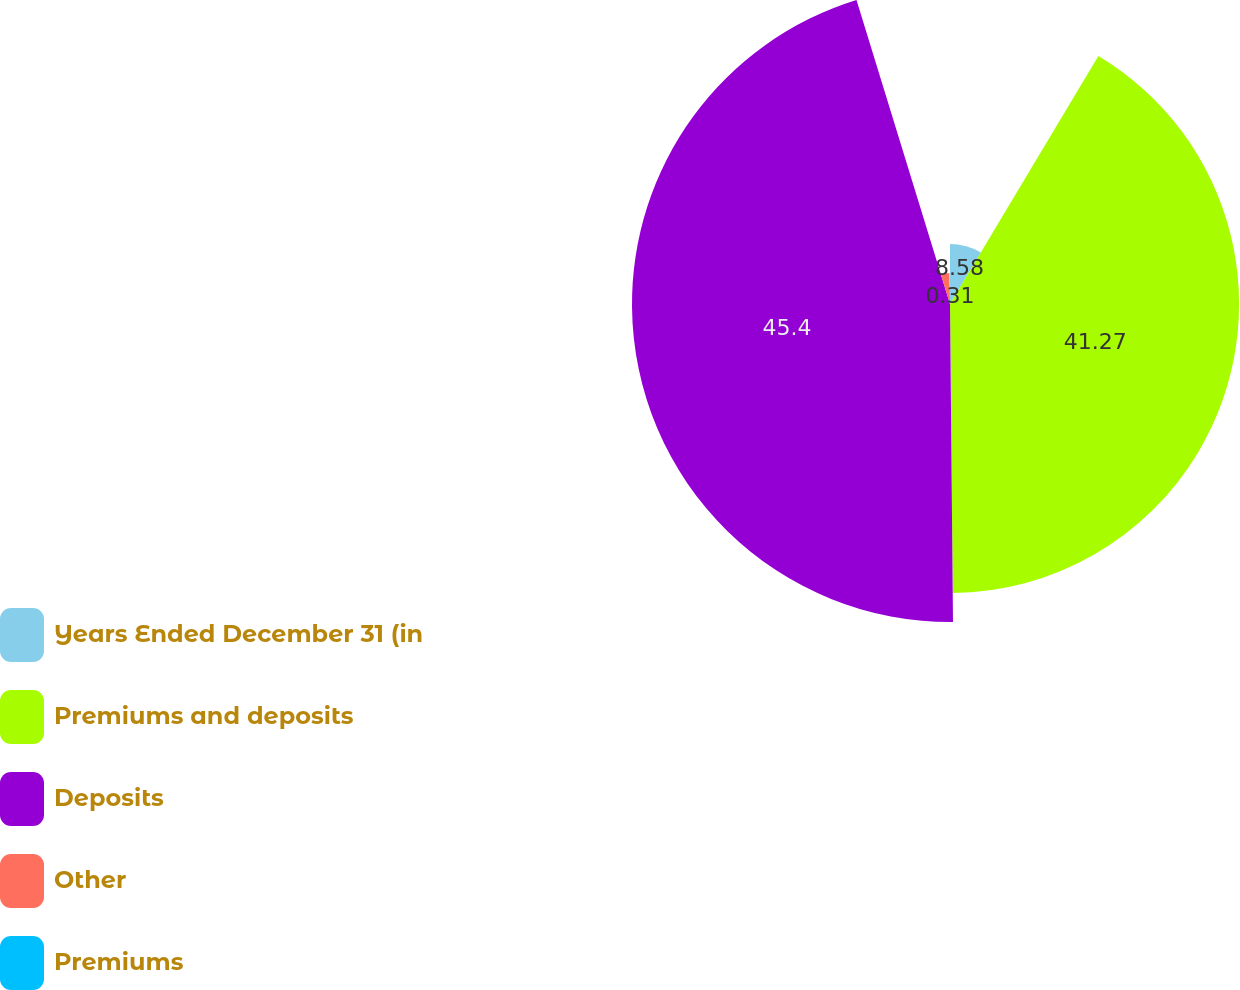Convert chart to OTSL. <chart><loc_0><loc_0><loc_500><loc_500><pie_chart><fcel>Years Ended December 31 (in<fcel>Premiums and deposits<fcel>Deposits<fcel>Other<fcel>Premiums<nl><fcel>8.58%<fcel>41.27%<fcel>45.4%<fcel>4.44%<fcel>0.31%<nl></chart> 